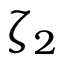<formula> <loc_0><loc_0><loc_500><loc_500>\zeta _ { 2 }</formula> 